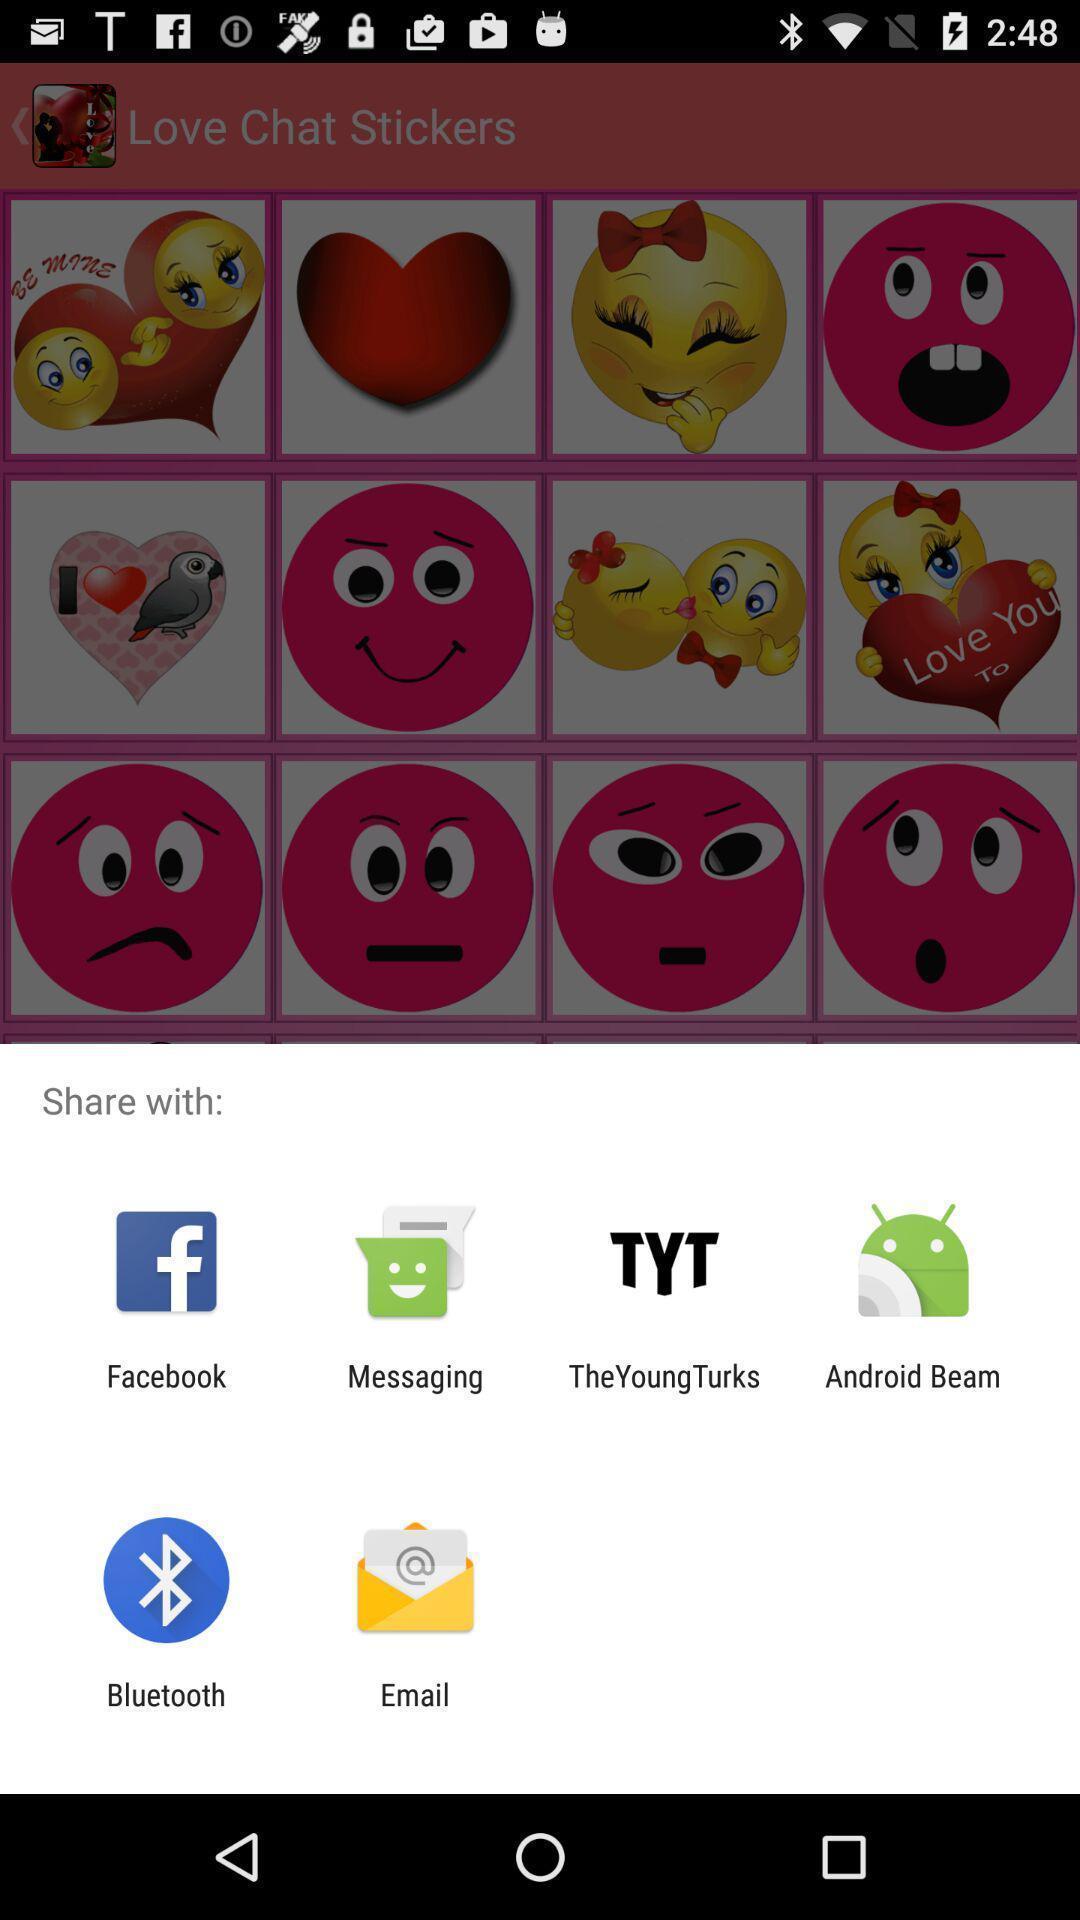Tell me what you see in this picture. Pop-up showing different share options. 